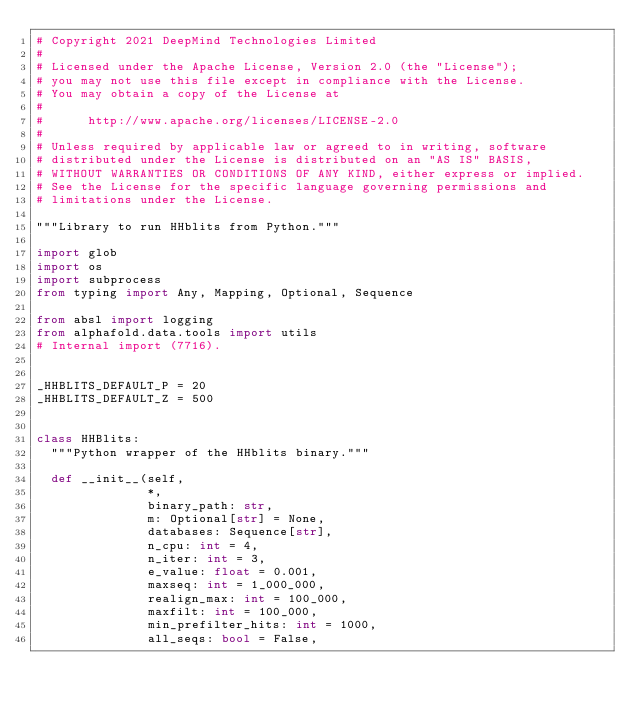<code> <loc_0><loc_0><loc_500><loc_500><_Python_># Copyright 2021 DeepMind Technologies Limited
#
# Licensed under the Apache License, Version 2.0 (the "License");
# you may not use this file except in compliance with the License.
# You may obtain a copy of the License at
#
#      http://www.apache.org/licenses/LICENSE-2.0
#
# Unless required by applicable law or agreed to in writing, software
# distributed under the License is distributed on an "AS IS" BASIS,
# WITHOUT WARRANTIES OR CONDITIONS OF ANY KIND, either express or implied.
# See the License for the specific language governing permissions and
# limitations under the License.

"""Library to run HHblits from Python."""

import glob
import os
import subprocess
from typing import Any, Mapping, Optional, Sequence

from absl import logging
from alphafold.data.tools import utils
# Internal import (7716).


_HHBLITS_DEFAULT_P = 20
_HHBLITS_DEFAULT_Z = 500


class HHBlits:
  """Python wrapper of the HHblits binary."""

  def __init__(self,
               *,
               binary_path: str,
               m: Optional[str] = None,
               databases: Sequence[str],
               n_cpu: int = 4,
               n_iter: int = 3,
               e_value: float = 0.001,
               maxseq: int = 1_000_000,
               realign_max: int = 100_000,
               maxfilt: int = 100_000,
               min_prefilter_hits: int = 1000,
               all_seqs: bool = False,</code> 